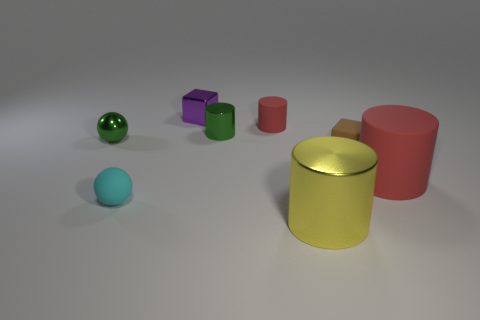Subtract 1 cylinders. How many cylinders are left? 3 Add 2 small cyan spheres. How many objects exist? 10 Subtract all blocks. How many objects are left? 6 Add 5 big red rubber things. How many big red rubber things exist? 6 Subtract 0 yellow cubes. How many objects are left? 8 Subtract all large blue matte cylinders. Subtract all green shiny objects. How many objects are left? 6 Add 4 purple cubes. How many purple cubes are left? 5 